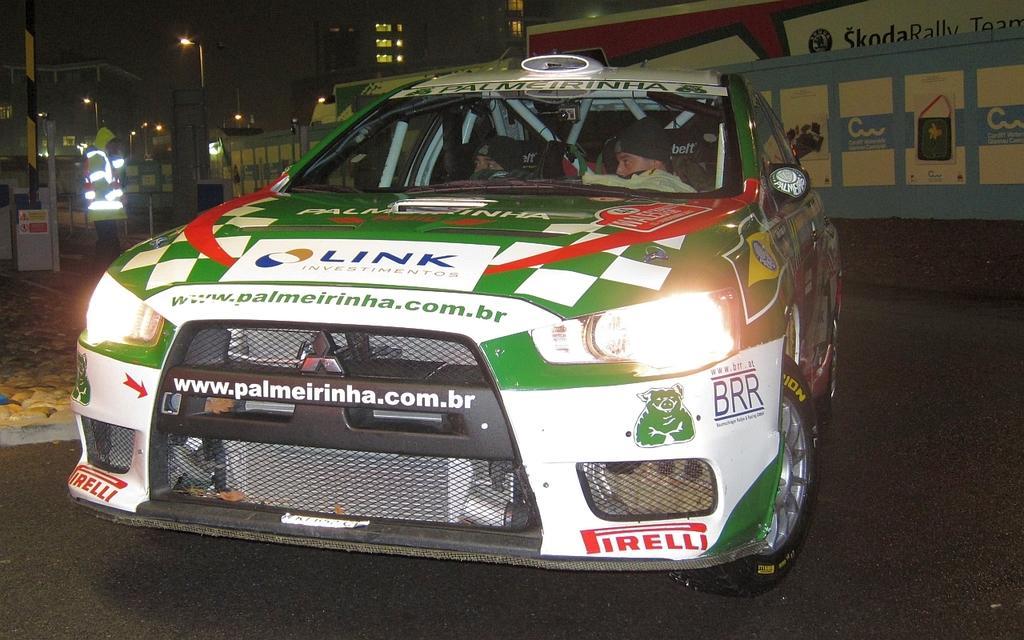Can you describe this image briefly? In the center of the image there is a car on the road. In the background of the image there are buildings. There are light poles. There is a wall with posters. 